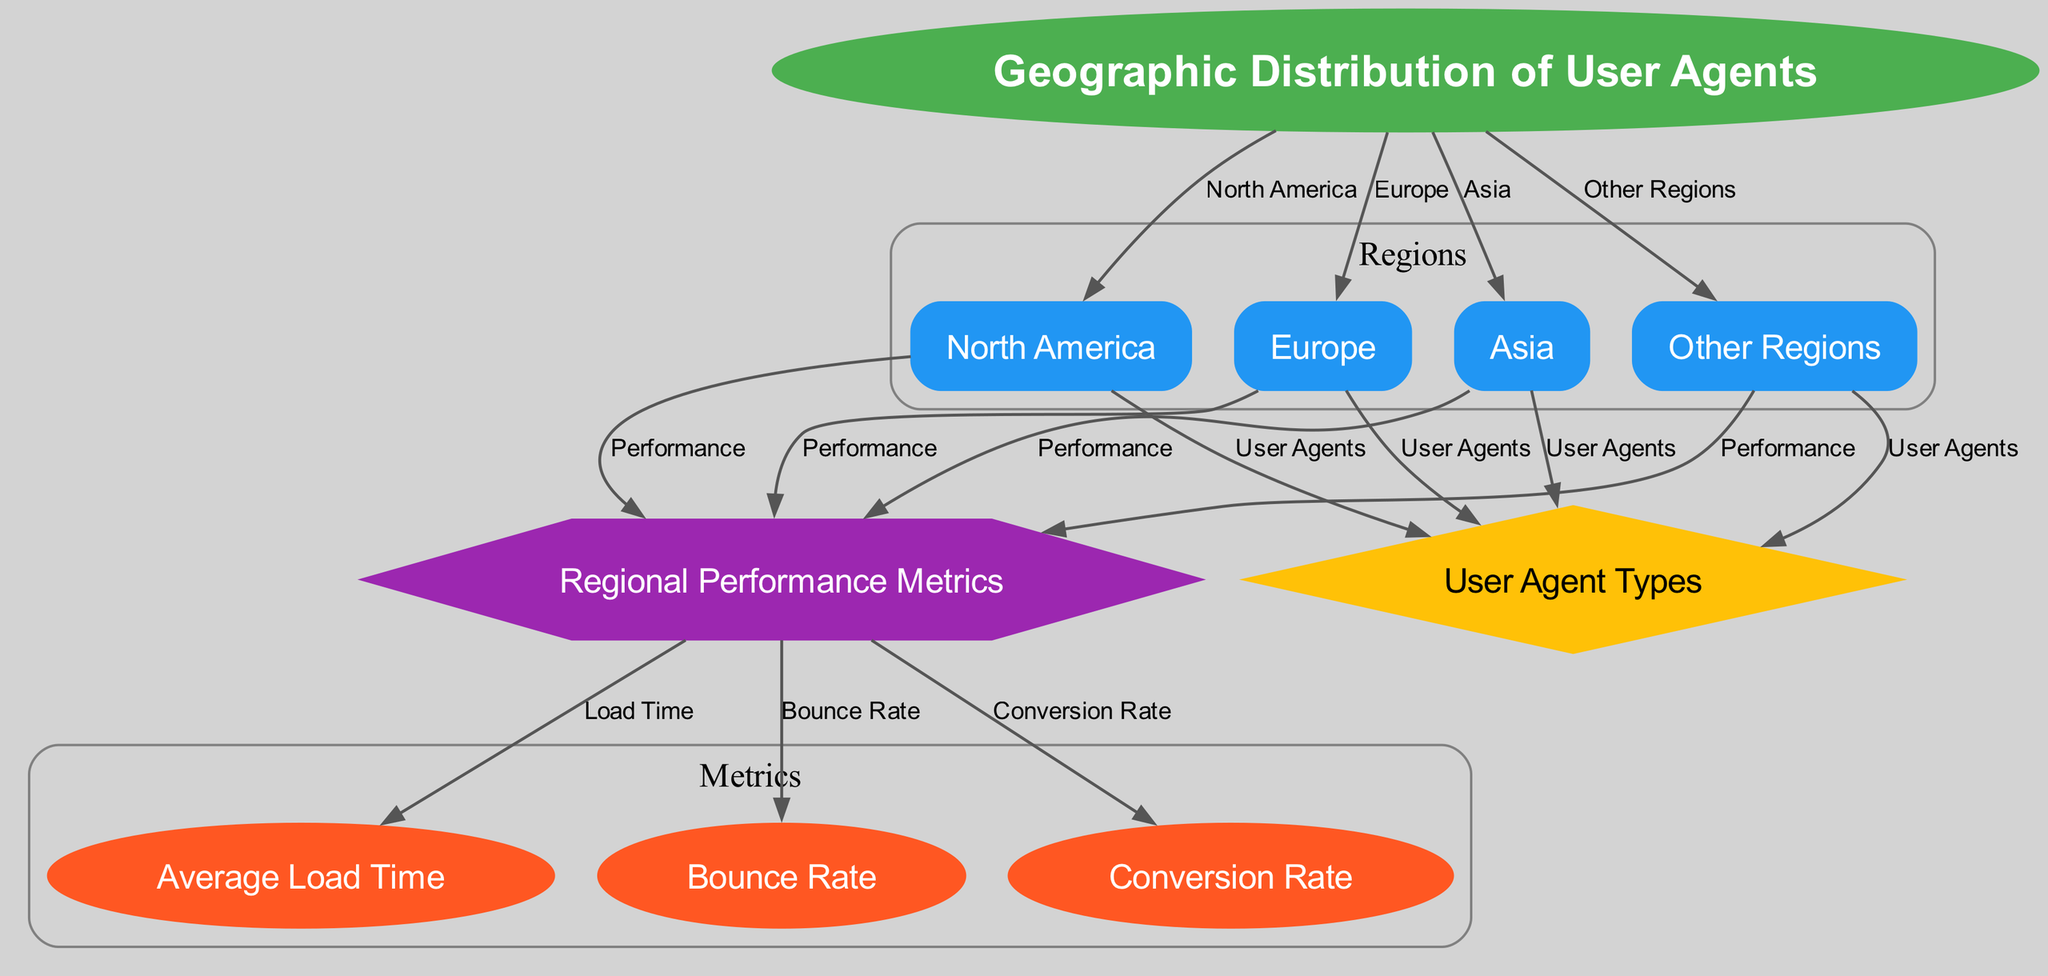What are the four primary regions represented in the diagram? The diagram includes four primary regions: North America, Europe, Asia, and Other Regions. This can be determined by identifying the nodes labeled with these region names connected to the central node labeled "Geographic Distribution of User Agents."
Answer: North America, Europe, Asia, Other Regions How many user agent types are depicted in the diagram? The diagram features a single node representing "User Agent Types," connected from all four regional nodes. Therefore, there is one distinct type of user agent illustrated in the diagram.
Answer: One What is the shape of the node labeled "Regional Performance Metrics"? In the diagram, the node labeled "Regional Performance Metrics" is shown as a hexagon. This can be confirmed visually by inspecting the styling assigned to this specific node in the rendered diagram.
Answer: Hexagon Which region shows a connection to all user agent types? All four regions (North America, Europe, Asia, Other Regions) are connected to the node labeled "User Agents." Hence, no single region uniquely connects to user agent types; they are collectively connected.
Answer: All regions What metrics are related to regional performance in the diagram? The regional performance metrics connected to the "Regional Performance Metrics" node include Average Load Time, Bounce Rate, and Conversion Rate. Each metric is distinctly attached to the performance node, allowing for easy identification.
Answer: Average Load Time, Bounce Rate, Conversion Rate Which region is linked to the highest user agent connections? While all regions connect to the user agents node, they do not indicate the quantity of connections. However, it can be reasoned each region has an equal connection to "User Agents." Hence, no region singularly stands out in the number of connections.
Answer: All are equal How does the diagram categorize user agents? According to the diagram, user agents are categorized based on the regions: North America, Europe, Asia, and Other Regions. This categorization is derived from looking at the edges linking each region to the user agents node.
Answer: By region What type of diagram is this? This is a "Textbook Diagram," which typically summarizes information visually by displaying relationships within data. This identification can be made based on its structure and the purpose of visualizing data relationships.
Answer: Textbook Diagram 